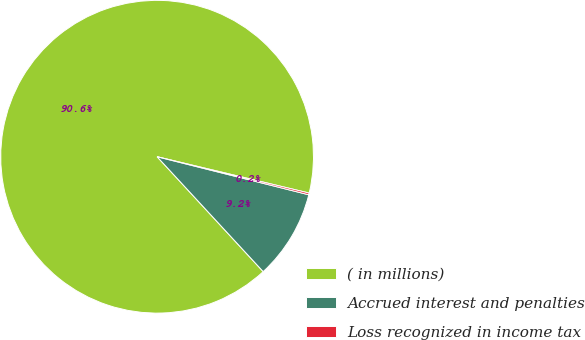Convert chart to OTSL. <chart><loc_0><loc_0><loc_500><loc_500><pie_chart><fcel>( in millions)<fcel>Accrued interest and penalties<fcel>Loss recognized in income tax<nl><fcel>90.6%<fcel>9.22%<fcel>0.18%<nl></chart> 